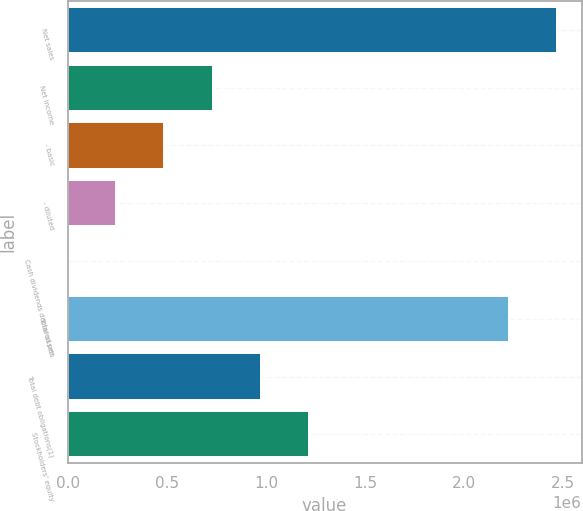Convert chart to OTSL. <chart><loc_0><loc_0><loc_500><loc_500><bar_chart><fcel>Net sales<fcel>Net income<fcel>- basic<fcel>- diluted<fcel>Cash dividends declared per<fcel>Total assets<fcel>Total debt obligations(1)<fcel>Stockholders' equity<nl><fcel>2.46947e+06<fcel>730682<fcel>487122<fcel>243561<fcel>0.6<fcel>2.22591e+06<fcel>974243<fcel>1.2178e+06<nl></chart> 